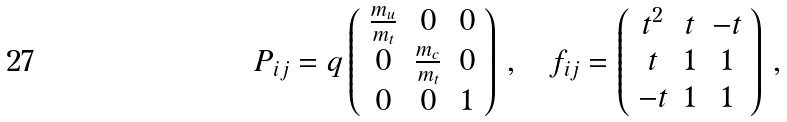<formula> <loc_0><loc_0><loc_500><loc_500>P _ { i j } = q \left ( \begin{array} { c c c } \frac { m _ { u } } { m _ { t } } & 0 & 0 \\ 0 & \frac { m _ { c } } { m _ { t } } & 0 \\ 0 & 0 & 1 \end{array} \right ) \, , \quad f _ { i j } = \left ( \begin{array} { c c c } t ^ { 2 } & t & - t \\ t & 1 & 1 \\ - t & 1 & 1 \end{array} \right ) \, ,</formula> 